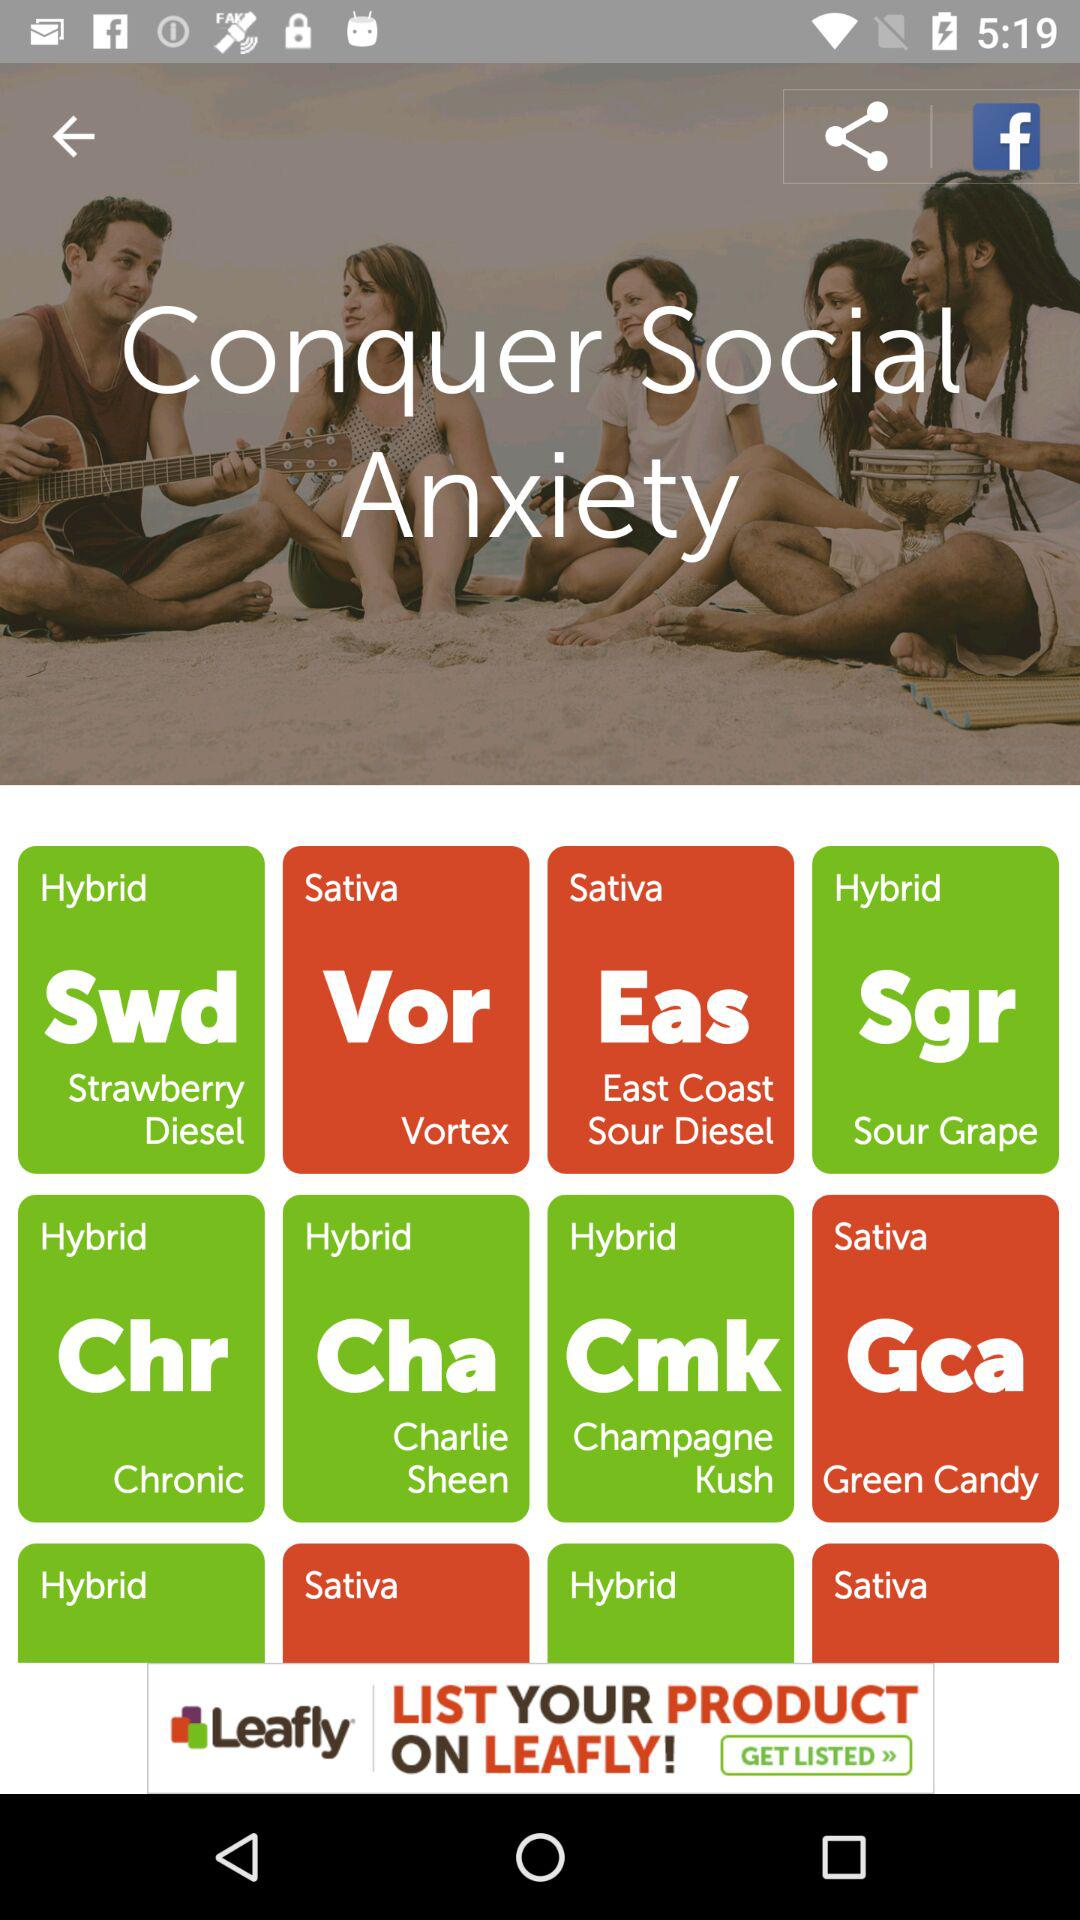What is the application name?
When the provided information is insufficient, respond with <no answer>. <no answer> 